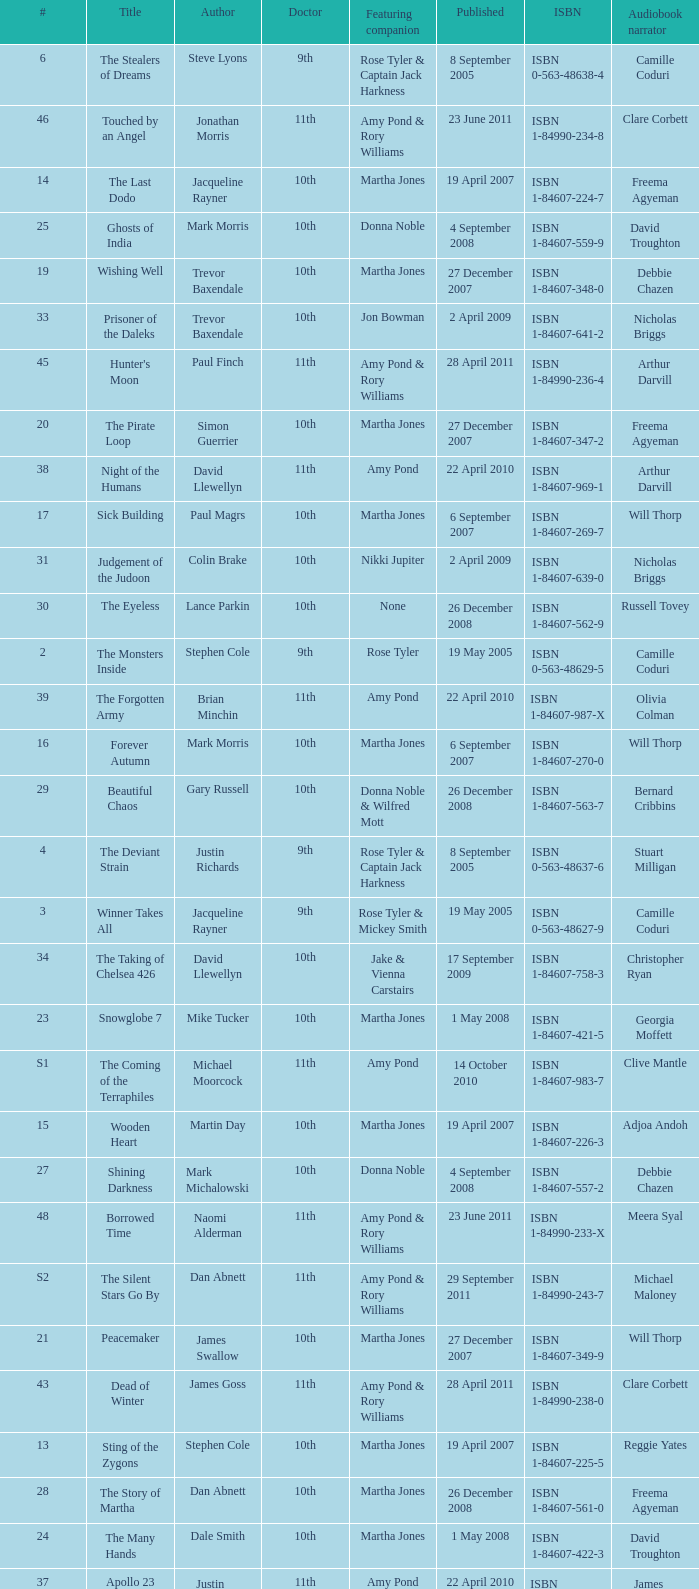Could you parse the entire table? {'header': ['#', 'Title', 'Author', 'Doctor', 'Featuring companion', 'Published', 'ISBN', 'Audiobook narrator'], 'rows': [['6', 'The Stealers of Dreams', 'Steve Lyons', '9th', 'Rose Tyler & Captain Jack Harkness', '8 September 2005', 'ISBN 0-563-48638-4', 'Camille Coduri'], ['46', 'Touched by an Angel', 'Jonathan Morris', '11th', 'Amy Pond & Rory Williams', '23 June 2011', 'ISBN 1-84990-234-8', 'Clare Corbett'], ['14', 'The Last Dodo', 'Jacqueline Rayner', '10th', 'Martha Jones', '19 April 2007', 'ISBN 1-84607-224-7', 'Freema Agyeman'], ['25', 'Ghosts of India', 'Mark Morris', '10th', 'Donna Noble', '4 September 2008', 'ISBN 1-84607-559-9', 'David Troughton'], ['19', 'Wishing Well', 'Trevor Baxendale', '10th', 'Martha Jones', '27 December 2007', 'ISBN 1-84607-348-0', 'Debbie Chazen'], ['33', 'Prisoner of the Daleks', 'Trevor Baxendale', '10th', 'Jon Bowman', '2 April 2009', 'ISBN 1-84607-641-2', 'Nicholas Briggs'], ['45', "Hunter's Moon", 'Paul Finch', '11th', 'Amy Pond & Rory Williams', '28 April 2011', 'ISBN 1-84990-236-4', 'Arthur Darvill'], ['20', 'The Pirate Loop', 'Simon Guerrier', '10th', 'Martha Jones', '27 December 2007', 'ISBN 1-84607-347-2', 'Freema Agyeman'], ['38', 'Night of the Humans', 'David Llewellyn', '11th', 'Amy Pond', '22 April 2010', 'ISBN 1-84607-969-1', 'Arthur Darvill'], ['17', 'Sick Building', 'Paul Magrs', '10th', 'Martha Jones', '6 September 2007', 'ISBN 1-84607-269-7', 'Will Thorp'], ['31', 'Judgement of the Judoon', 'Colin Brake', '10th', 'Nikki Jupiter', '2 April 2009', 'ISBN 1-84607-639-0', 'Nicholas Briggs'], ['30', 'The Eyeless', 'Lance Parkin', '10th', 'None', '26 December 2008', 'ISBN 1-84607-562-9', 'Russell Tovey'], ['2', 'The Monsters Inside', 'Stephen Cole', '9th', 'Rose Tyler', '19 May 2005', 'ISBN 0-563-48629-5', 'Camille Coduri'], ['39', 'The Forgotten Army', 'Brian Minchin', '11th', 'Amy Pond', '22 April 2010', 'ISBN 1-84607-987-X', 'Olivia Colman'], ['16', 'Forever Autumn', 'Mark Morris', '10th', 'Martha Jones', '6 September 2007', 'ISBN 1-84607-270-0', 'Will Thorp'], ['29', 'Beautiful Chaos', 'Gary Russell', '10th', 'Donna Noble & Wilfred Mott', '26 December 2008', 'ISBN 1-84607-563-7', 'Bernard Cribbins'], ['4', 'The Deviant Strain', 'Justin Richards', '9th', 'Rose Tyler & Captain Jack Harkness', '8 September 2005', 'ISBN 0-563-48637-6', 'Stuart Milligan'], ['3', 'Winner Takes All', 'Jacqueline Rayner', '9th', 'Rose Tyler & Mickey Smith', '19 May 2005', 'ISBN 0-563-48627-9', 'Camille Coduri'], ['34', 'The Taking of Chelsea 426', 'David Llewellyn', '10th', 'Jake & Vienna Carstairs', '17 September 2009', 'ISBN 1-84607-758-3', 'Christopher Ryan'], ['23', 'Snowglobe 7', 'Mike Tucker', '10th', 'Martha Jones', '1 May 2008', 'ISBN 1-84607-421-5', 'Georgia Moffett'], ['S1', 'The Coming of the Terraphiles', 'Michael Moorcock', '11th', 'Amy Pond', '14 October 2010', 'ISBN 1-84607-983-7', 'Clive Mantle'], ['15', 'Wooden Heart', 'Martin Day', '10th', 'Martha Jones', '19 April 2007', 'ISBN 1-84607-226-3', 'Adjoa Andoh'], ['27', 'Shining Darkness', 'Mark Michalowski', '10th', 'Donna Noble', '4 September 2008', 'ISBN 1-84607-557-2', 'Debbie Chazen'], ['48', 'Borrowed Time', 'Naomi Alderman', '11th', 'Amy Pond & Rory Williams', '23 June 2011', 'ISBN 1-84990-233-X', 'Meera Syal'], ['S2', 'The Silent Stars Go By', 'Dan Abnett', '11th', 'Amy Pond & Rory Williams', '29 September 2011', 'ISBN 1-84990-243-7', 'Michael Maloney'], ['21', 'Peacemaker', 'James Swallow', '10th', 'Martha Jones', '27 December 2007', 'ISBN 1-84607-349-9', 'Will Thorp'], ['43', 'Dead of Winter', 'James Goss', '11th', 'Amy Pond & Rory Williams', '28 April 2011', 'ISBN 1-84990-238-0', 'Clare Corbett'], ['13', 'Sting of the Zygons', 'Stephen Cole', '10th', 'Martha Jones', '19 April 2007', 'ISBN 1-84607-225-5', 'Reggie Yates'], ['28', 'The Story of Martha', 'Dan Abnett', '10th', 'Martha Jones', '26 December 2008', 'ISBN 1-84607-561-0', 'Freema Agyeman'], ['24', 'The Many Hands', 'Dale Smith', '10th', 'Martha Jones', '1 May 2008', 'ISBN 1-84607-422-3', 'David Troughton'], ['37', 'Apollo 23', 'Justin Richards', '11th', 'Amy Pond', '22 April 2010', 'ISBN 1-84607-200-X', 'James Albrecht'], ['32', 'The Slitheen Excursion', 'Simon Guerrier', '10th', 'June Walsh', '2 April 2009', 'ISBN 1-84607-640-4', 'Debbie Chazen'], ['41', "The King's Dragon", 'Una McCormack', '11th', 'Amy Pond & Rory Williams', '8 July 2010', 'ISBN 1-84607-990-X', 'Nicholas Briggs'], ['36', 'The Krillitane Storm', 'Christopher Cooper', '10th', 'Emily Parr', '17 September 2009', 'ISBN 1-84607-761-3', 'Will Thorp'], ['26', 'The Doctor Trap', 'Simon Messingham', '10th', 'Donna Noble', '4 September 2008', 'ISBN 1-84607-558-0', 'Russell Tovey'], ['10', 'The Nightmare of Black Island', 'Mike Tucker', '10th', 'Rose Tyler', '21 September 2006', 'ISBN 0-563-48650-3', 'Anthony Head'], ['S3', 'Dark Horizons', 'J T Colgan', '11th', 'None', '7 July 2012', 'ISBN 1-84990-456-1', 'Neve McIntosh'], ['44', 'The Way Through the Woods', 'Una McCormack', '11th', 'Amy Pond & Rory Williams', '28 April 2011', 'ISBN 1-84990-237-2', 'Clare Corbett'], ['9', 'The Resurrection Casket', 'Justin Richards', '10th', 'Rose Tyler', '13 April 2006', 'ISBN 0-563-48642-2', 'David Tennant'], ['22', 'Martha in the Mirror', 'Justin Richards', '10th', 'Martha Jones', '1 May 2008', 'ISBN 1-84607-420-7', 'Freema Agyeman'], ['35', 'Autonomy', 'Daniel Blythe', '10th', 'Kate Maguire', '17 September 2009', 'ISBN 1-84607-759-1', 'Georgia Moffett'], ['40', 'Nuclear Time', 'Oli Smith', '11th', 'Amy Pond & Rory Williams', '8 July 2010', 'ISBN 1-84607-989-6', 'Nicholas Briggs'], ['1', 'The Clockwise Man', 'Justin Richards', '9th', 'Rose Tyler', '19 May 2005', 'ISBN 0-563-48628-7', 'Nicholas Briggs'], ['47', 'Paradox Lost', 'George Mann', '11th', 'Amy Pond & Rory Williams', '23 June 2011', 'ISBN 1-84990-235-6', 'Nicholas Briggs'], ['11', 'The Art of Destruction', 'Stephen Cole', '10th', 'Rose Tyler', '21 September 2006', 'ISBN 0-563-48651-1', 'Don Warrington'], ['18', 'Wetworld', 'Mark Michalowski', '10th', 'Martha Jones', '6 September 2007', 'ISBN 1-84607-271-9', 'Freema Agyeman'], ['8', 'The Feast of the Drowned', 'Stephen Cole', '10th', 'Rose Tyler & Mickey Smith', '13 April 2006', 'ISBN 0-563-48644-9', 'David Tennant'], ['12', 'The Price of Paradise', 'Colin Brake', '10th', 'Rose Tyler', '21 September 2006', 'ISBN 0-563-48652-X', 'Shaun Dingwall'], ['7', 'The Stone Rose', 'Jacqueline Rayner', '10th', 'Rose Tyler & Mickey Smith', '13 April 2006', 'ISBN 0-563-48643-0', 'David Tennant'], ['42', 'The Glamour Chase', 'Gary Russell', '11th', 'Amy Pond & Rory Williams', '8 July 2010', 'ISBN 1-84607-988-8', 'Arthur Darvill'], ['5', 'Only Human', 'Gareth Roberts', '9th', 'Rose Tyler & Captain Jack Harkness', '8 September 2005', 'ISBN 0-563-48639-2', 'Anthony Head']]} What is the title of book number 7? The Stone Rose. 